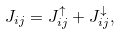Convert formula to latex. <formula><loc_0><loc_0><loc_500><loc_500>J _ { i j } = J ^ { \uparrow } _ { i j } + J ^ { \downarrow } _ { i j } ,</formula> 